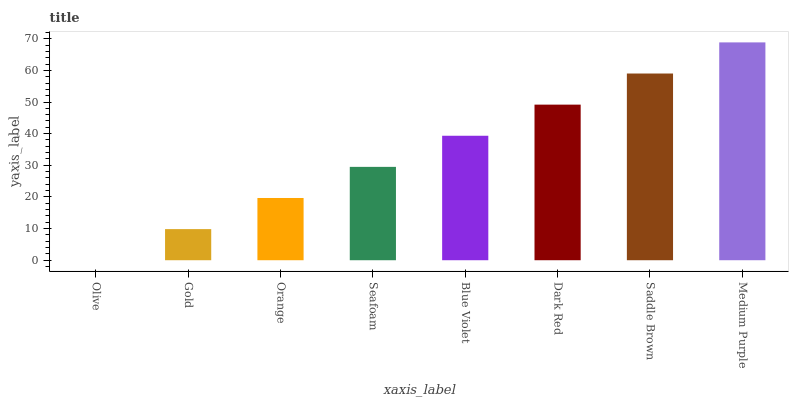Is Olive the minimum?
Answer yes or no. Yes. Is Medium Purple the maximum?
Answer yes or no. Yes. Is Gold the minimum?
Answer yes or no. No. Is Gold the maximum?
Answer yes or no. No. Is Gold greater than Olive?
Answer yes or no. Yes. Is Olive less than Gold?
Answer yes or no. Yes. Is Olive greater than Gold?
Answer yes or no. No. Is Gold less than Olive?
Answer yes or no. No. Is Blue Violet the high median?
Answer yes or no. Yes. Is Seafoam the low median?
Answer yes or no. Yes. Is Dark Red the high median?
Answer yes or no. No. Is Medium Purple the low median?
Answer yes or no. No. 